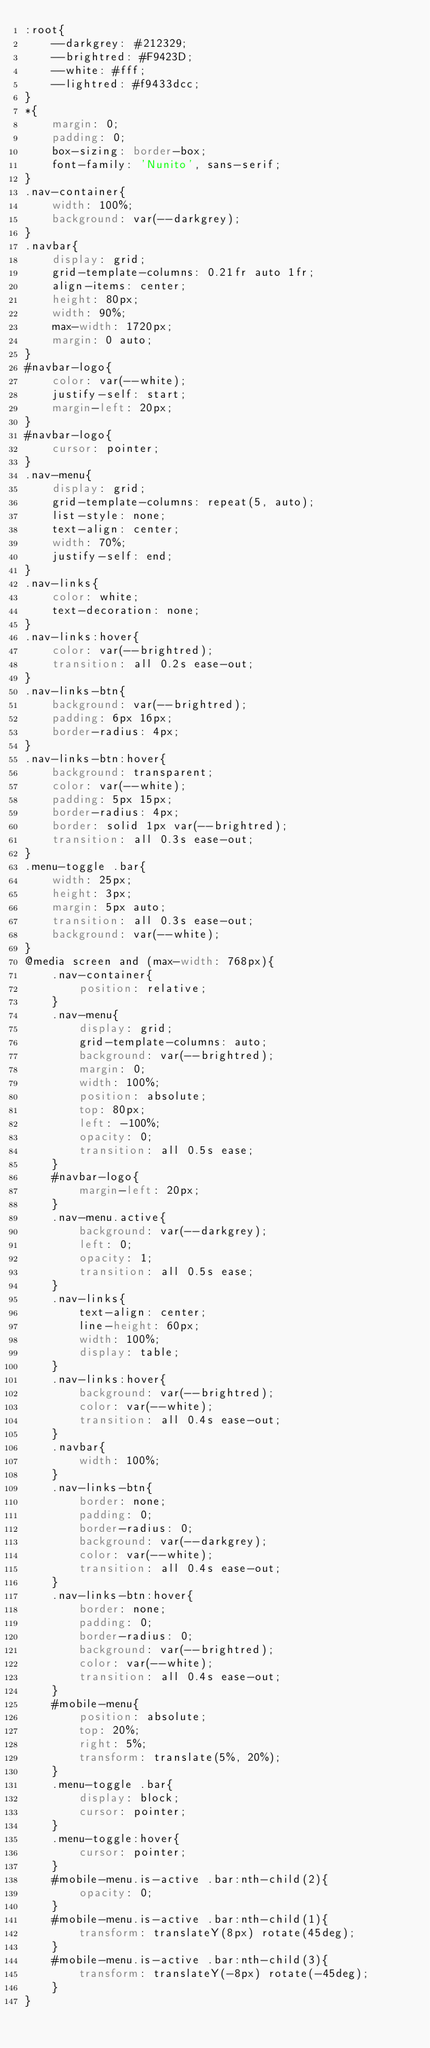<code> <loc_0><loc_0><loc_500><loc_500><_CSS_>:root{
    --darkgrey: #212329;
    --brightred: #F9423D;
    --white: #fff;
    --lightred: #f9433dcc;
}
*{
    margin: 0;
    padding: 0;
    box-sizing: border-box;
    font-family: 'Nunito', sans-serif;
}
.nav-container{
    width: 100%;
    background: var(--darkgrey);
}
.navbar{
    display: grid;
    grid-template-columns: 0.21fr auto 1fr;
    align-items: center;
    height: 80px;
    width: 90%;
    max-width: 1720px;
    margin: 0 auto;
}
#navbar-logo{
    color: var(--white);
    justify-self: start;
    margin-left: 20px;
}
#navbar-logo{
    cursor: pointer;
}
.nav-menu{
    display: grid;
    grid-template-columns: repeat(5, auto);
    list-style: none;
    text-align: center;
    width: 70%;
    justify-self: end;
}
.nav-links{
    color: white;
    text-decoration: none;
}
.nav-links:hover{
    color: var(--brightred);
    transition: all 0.2s ease-out;
}
.nav-links-btn{
    background: var(--brightred);
    padding: 6px 16px;
    border-radius: 4px;
}
.nav-links-btn:hover{
    background: transparent;
    color: var(--white);
    padding: 5px 15px;
    border-radius: 4px;
    border: solid 1px var(--brightred);
    transition: all 0.3s ease-out;
}
.menu-toggle .bar{
    width: 25px;
    height: 3px;
    margin: 5px auto;
    transition: all 0.3s ease-out;
    background: var(--white);
}
@media screen and (max-width: 768px){
    .nav-container{
        position: relative;
    }
    .nav-menu{
        display: grid;
        grid-template-columns: auto;
        background: var(--brightred);
        margin: 0;
        width: 100%;
        position: absolute;
        top: 80px;
        left: -100%;
        opacity: 0;
        transition: all 0.5s ease;
    }
    #navbar-logo{
        margin-left: 20px;
    }
    .nav-menu.active{
        background: var(--darkgrey);
        left: 0;
        opacity: 1;
        transition: all 0.5s ease;
    }
    .nav-links{
        text-align: center;
        line-height: 60px;
        width: 100%;
        display: table;
    }
    .nav-links:hover{
        background: var(--brightred);
        color: var(--white);
        transition: all 0.4s ease-out;
    }
    .navbar{
        width: 100%;
    }
    .nav-links-btn{
        border: none;
        padding: 0;
        border-radius: 0;
        background: var(--darkgrey);
        color: var(--white);
        transition: all 0.4s ease-out;
    }
    .nav-links-btn:hover{
        border: none;
        padding: 0;
        border-radius: 0;
        background: var(--brightred);
        color: var(--white);
        transition: all 0.4s ease-out;
    }
    #mobile-menu{
        position: absolute;
        top: 20%;
        right: 5%;
        transform: translate(5%, 20%);
    }
    .menu-toggle .bar{
        display: block;
        cursor: pointer;
    }
    .menu-toggle:hover{
        cursor: pointer;
    }
    #mobile-menu.is-active .bar:nth-child(2){
        opacity: 0;
    }
    #mobile-menu.is-active .bar:nth-child(1){
        transform: translateY(8px) rotate(45deg);
    }
    #mobile-menu.is-active .bar:nth-child(3){
        transform: translateY(-8px) rotate(-45deg);
    }
}</code> 